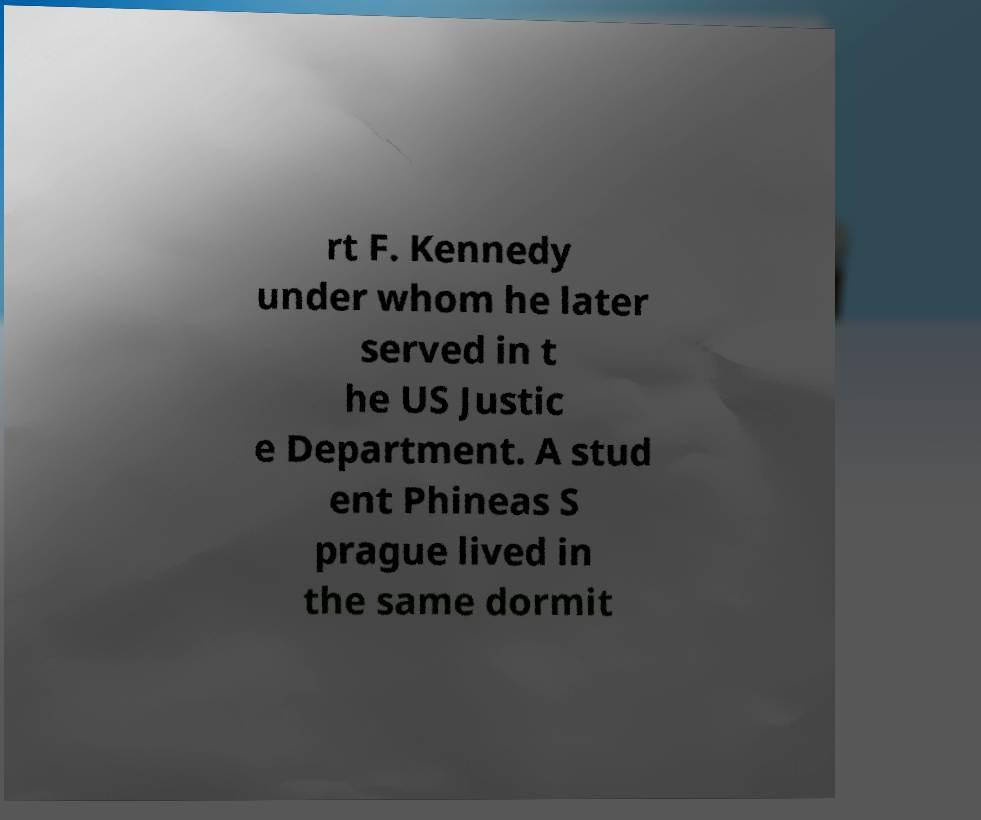I need the written content from this picture converted into text. Can you do that? rt F. Kennedy under whom he later served in t he US Justic e Department. A stud ent Phineas S prague lived in the same dormit 